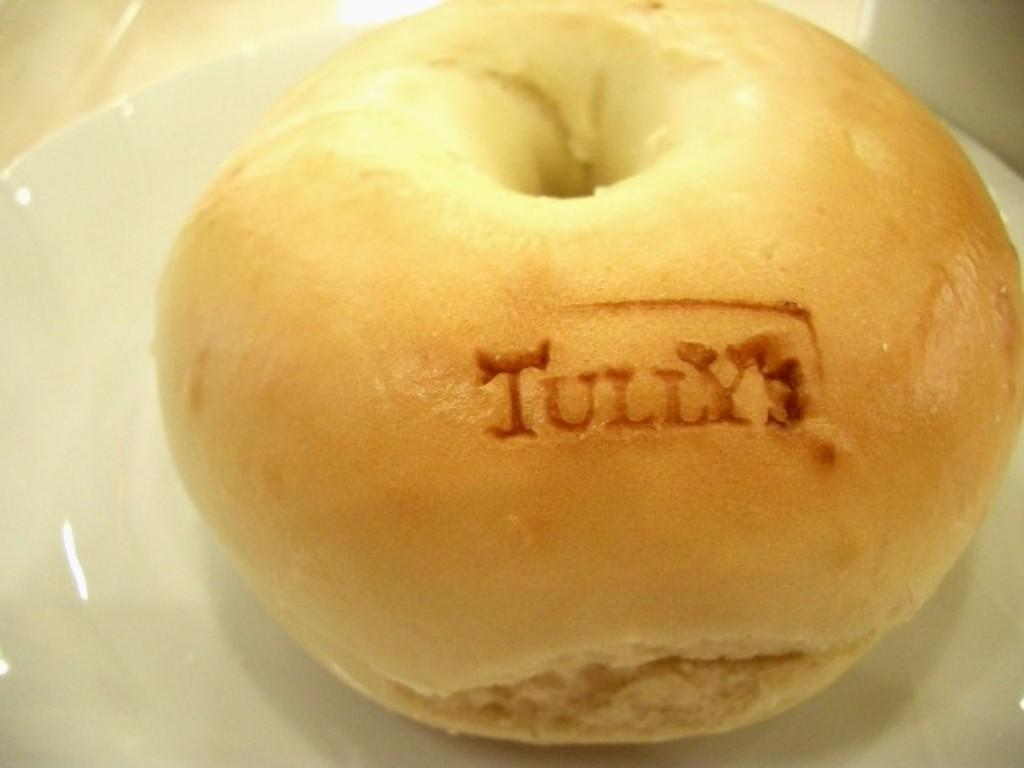What is the main subject of the image? The main subject of the image is a food item on a plate. Can you describe the placement of the food item on the plate? The food item is in the center of the plate. How many legs can be seen supporting the chess board in the image? There is no chess board or legs present in the image; it features a food item on a plate. What type of hook is used to hang the food item on the plate? There is no hook used to hang the food item on the plate; it is simply placed on the plate. 